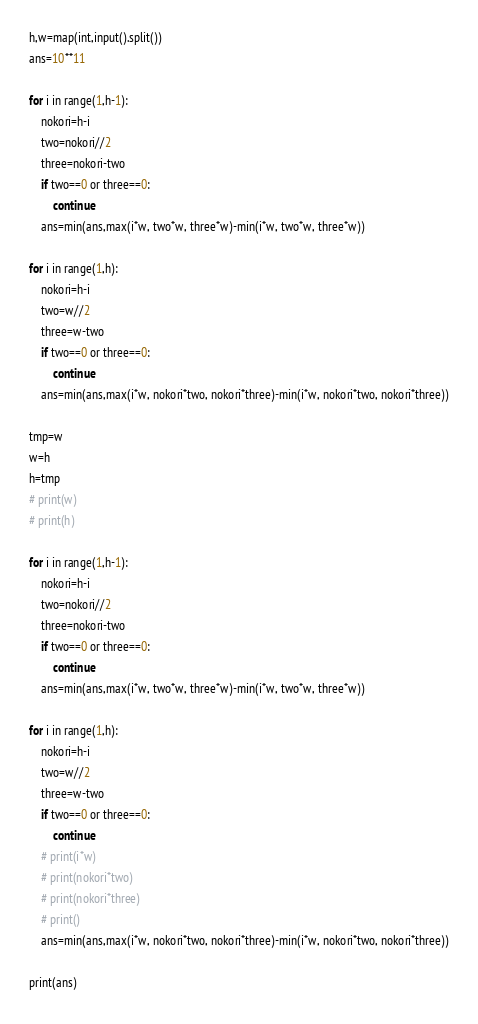<code> <loc_0><loc_0><loc_500><loc_500><_Python_>h,w=map(int,input().split())
ans=10**11

for i in range(1,h-1):
    nokori=h-i
    two=nokori//2
    three=nokori-two
    if two==0 or three==0:
        continue
    ans=min(ans,max(i*w, two*w, three*w)-min(i*w, two*w, three*w))

for i in range(1,h):
    nokori=h-i
    two=w//2
    three=w-two
    if two==0 or three==0:
        continue
    ans=min(ans,max(i*w, nokori*two, nokori*three)-min(i*w, nokori*two, nokori*three))

tmp=w
w=h
h=tmp
# print(w)
# print(h)

for i in range(1,h-1):
    nokori=h-i
    two=nokori//2
    three=nokori-two
    if two==0 or three==0:
        continue
    ans=min(ans,max(i*w, two*w, three*w)-min(i*w, two*w, three*w))

for i in range(1,h):
    nokori=h-i
    two=w//2
    three=w-two
    if two==0 or three==0:
        continue
    # print(i*w)
    # print(nokori*two)
    # print(nokori*three)
    # print()
    ans=min(ans,max(i*w, nokori*two, nokori*three)-min(i*w, nokori*two, nokori*three))

print(ans)</code> 